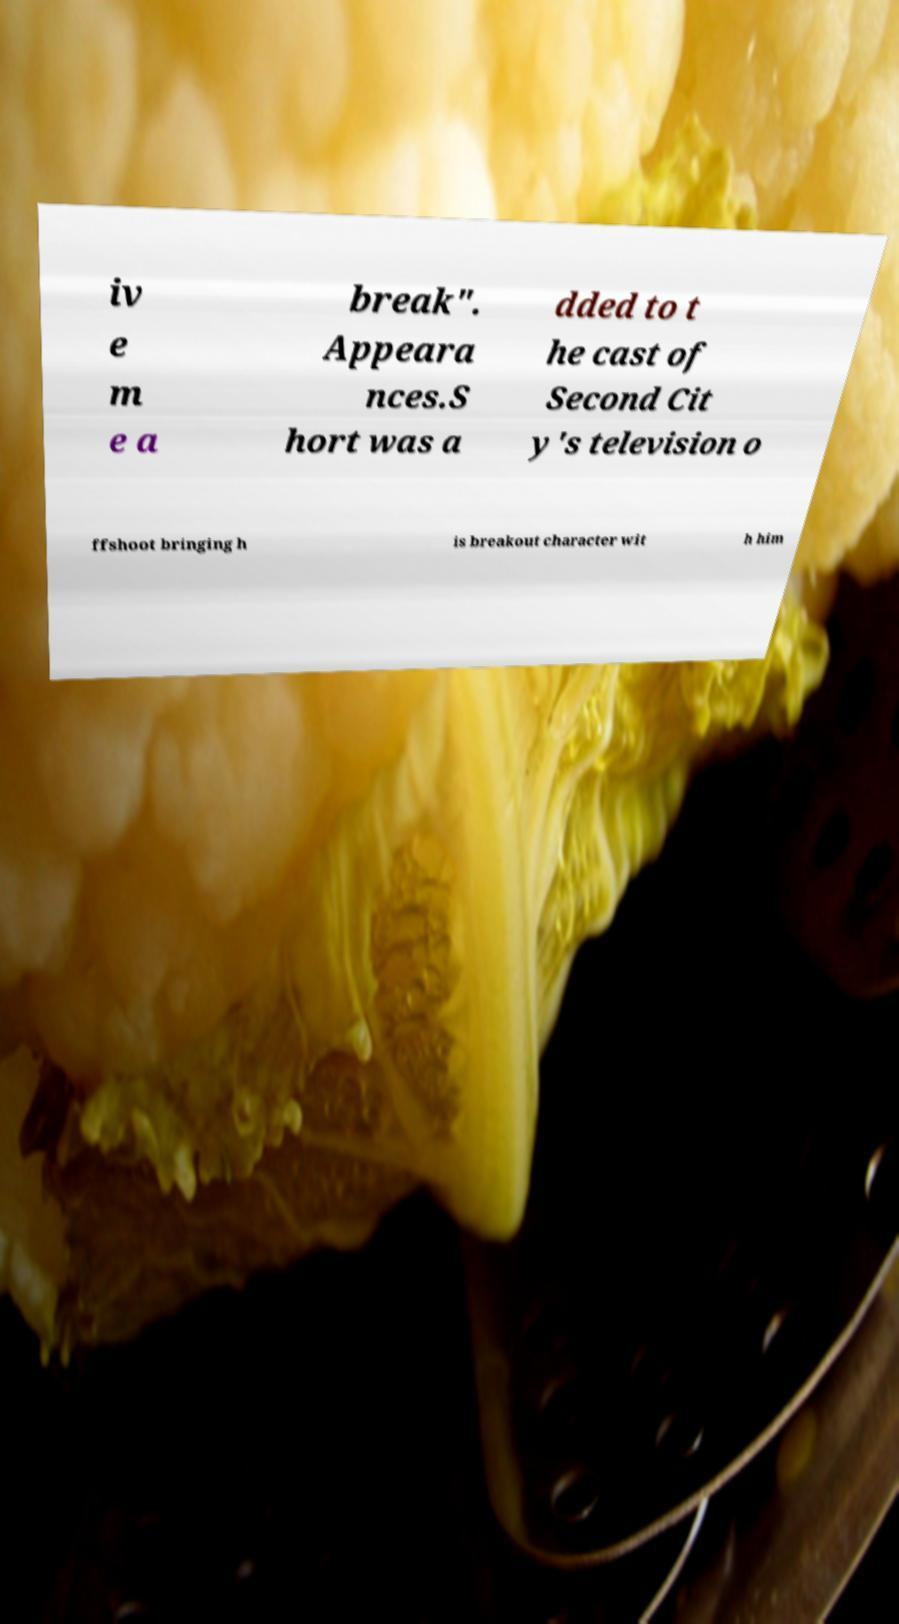There's text embedded in this image that I need extracted. Can you transcribe it verbatim? iv e m e a break". Appeara nces.S hort was a dded to t he cast of Second Cit y's television o ffshoot bringing h is breakout character wit h him 